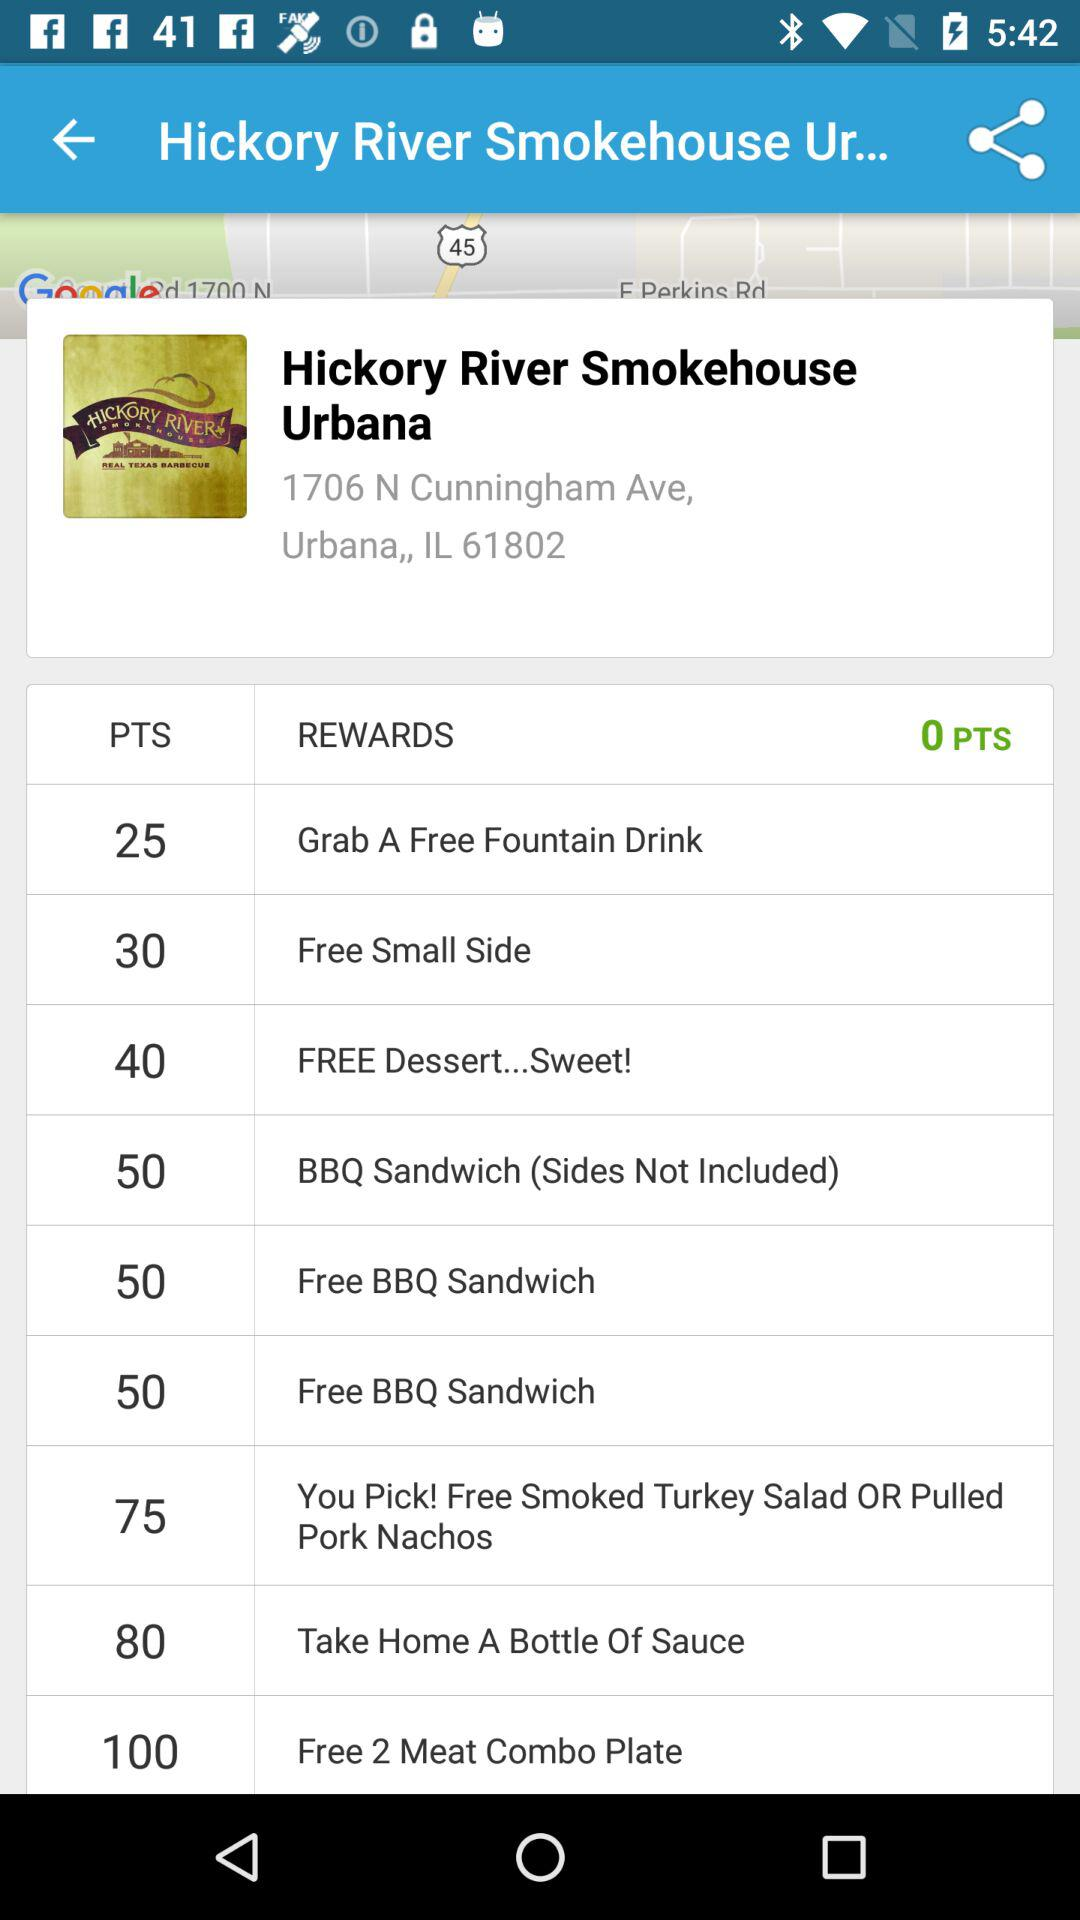How many points are there for a reward named "FREE Dessert...Sweet!"?
Answer the question using a single word or phrase. There are 40 points 